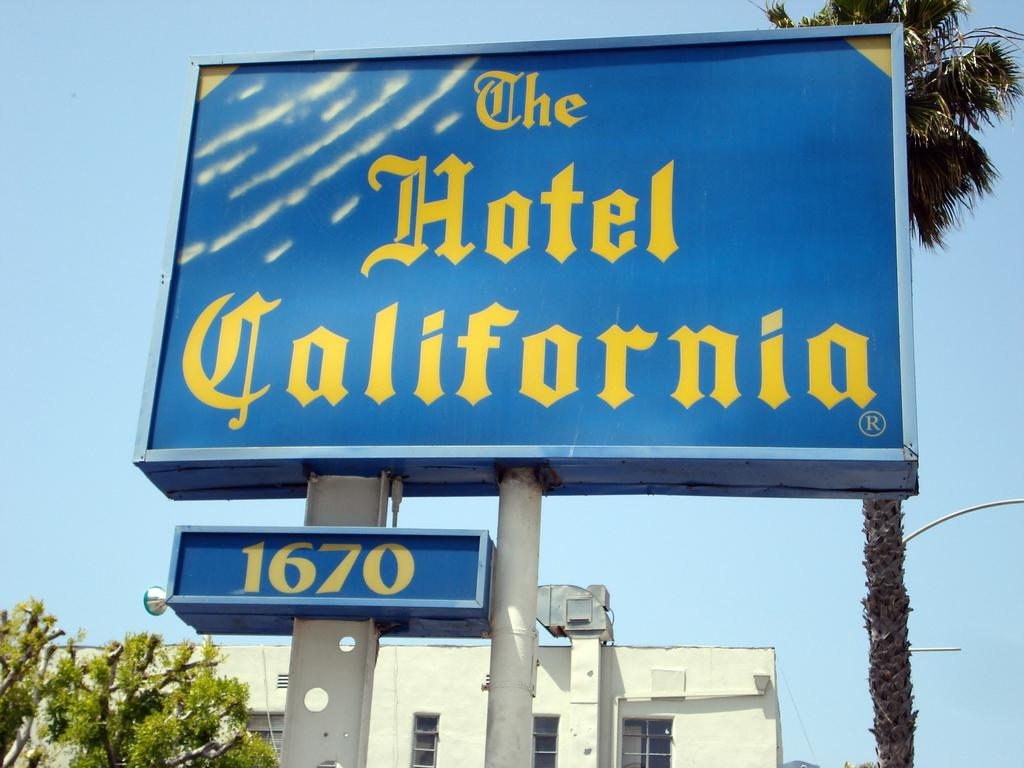Provide a one-sentence caption for the provided image. a blue and yellow sign for The Hotel California 1670. 